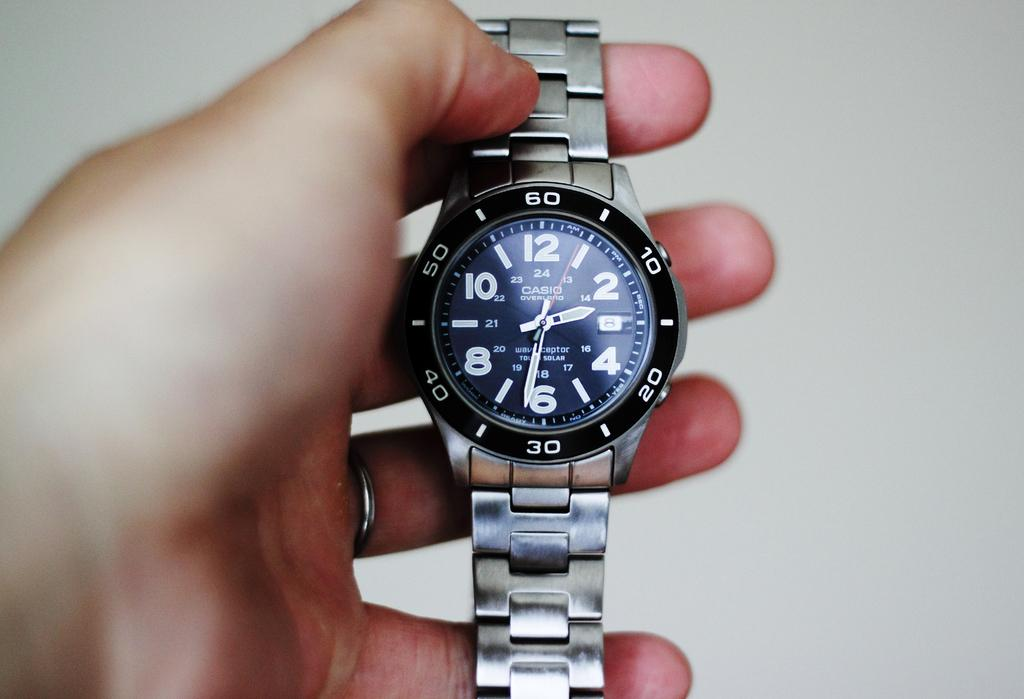<image>
Render a clear and concise summary of the photo. A Casio overland watch is being held up by someone. 